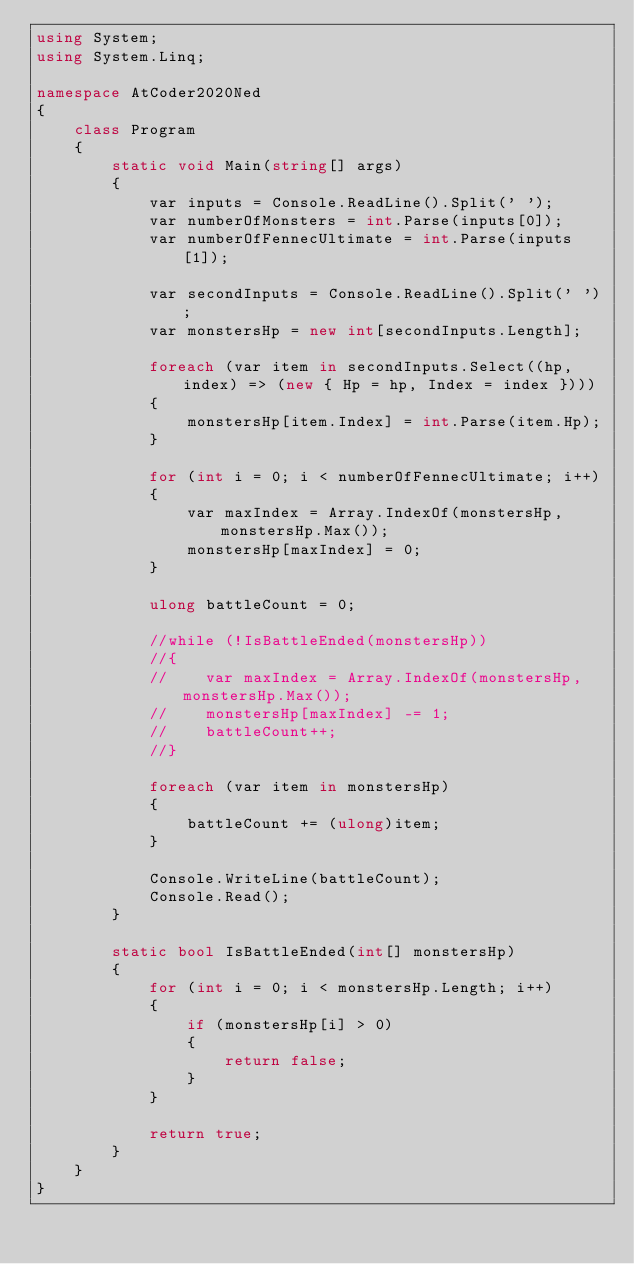<code> <loc_0><loc_0><loc_500><loc_500><_C#_>using System;
using System.Linq;

namespace AtCoder2020Ned
{
    class Program
    {
        static void Main(string[] args)
        {
            var inputs = Console.ReadLine().Split(' ');
            var numberOfMonsters = int.Parse(inputs[0]);
            var numberOfFennecUltimate = int.Parse(inputs[1]);

            var secondInputs = Console.ReadLine().Split(' ');
            var monstersHp = new int[secondInputs.Length];

            foreach (var item in secondInputs.Select((hp, index) => (new { Hp = hp, Index = index })))
            {
                monstersHp[item.Index] = int.Parse(item.Hp);
            }

            for (int i = 0; i < numberOfFennecUltimate; i++)
            {
                var maxIndex = Array.IndexOf(monstersHp, monstersHp.Max());
                monstersHp[maxIndex] = 0;
            }

            ulong battleCount = 0;

            //while (!IsBattleEnded(monstersHp))
            //{
            //    var maxIndex = Array.IndexOf(monstersHp, monstersHp.Max());
            //    monstersHp[maxIndex] -= 1;
            //    battleCount++;
            //}

            foreach (var item in monstersHp)
            {
                battleCount += (ulong)item;
            }

            Console.WriteLine(battleCount);
            Console.Read();
        }

        static bool IsBattleEnded(int[] monstersHp)
        {
            for (int i = 0; i < monstersHp.Length; i++)
            {
                if (monstersHp[i] > 0)
                {
                    return false;
                }
            }

            return true;
        }
    }
}
</code> 